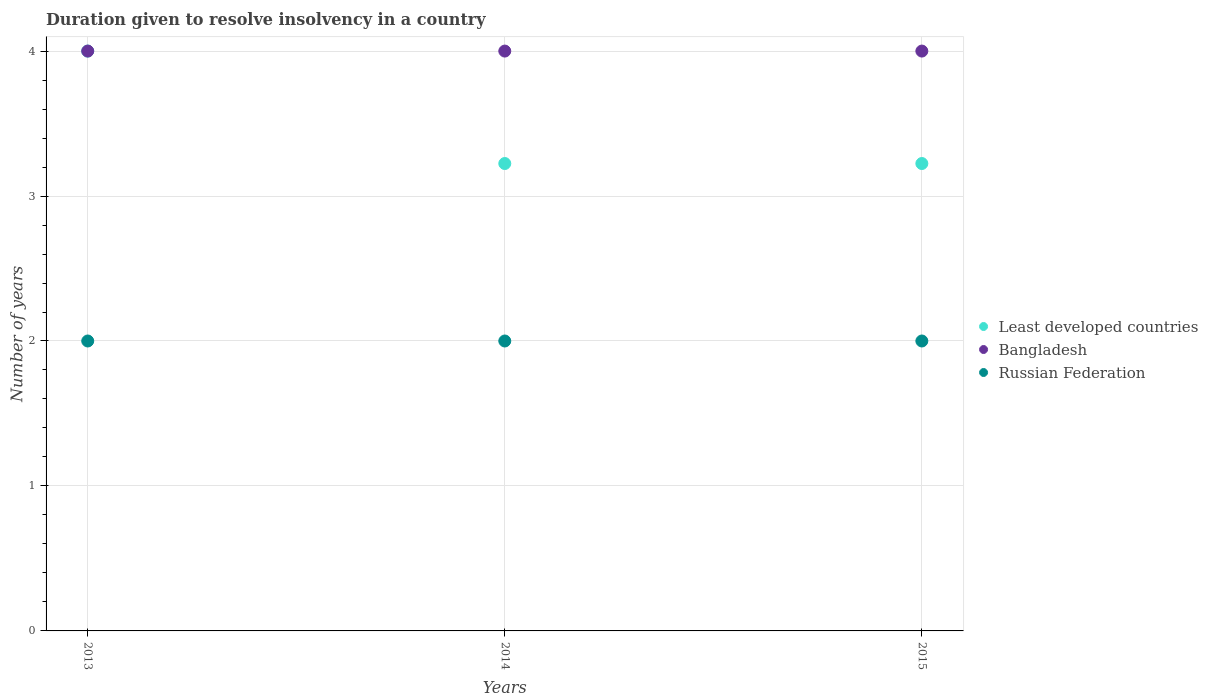Is the number of dotlines equal to the number of legend labels?
Ensure brevity in your answer.  Yes. What is the duration given to resolve insolvency in in Russian Federation in 2014?
Give a very brief answer. 2. Across all years, what is the maximum duration given to resolve insolvency in in Least developed countries?
Your response must be concise. 4. Across all years, what is the minimum duration given to resolve insolvency in in Least developed countries?
Offer a terse response. 3.22. In which year was the duration given to resolve insolvency in in Russian Federation maximum?
Provide a short and direct response. 2013. What is the total duration given to resolve insolvency in in Bangladesh in the graph?
Your answer should be very brief. 12. What is the difference between the duration given to resolve insolvency in in Russian Federation in 2015 and the duration given to resolve insolvency in in Bangladesh in 2014?
Keep it short and to the point. -2. What is the average duration given to resolve insolvency in in Least developed countries per year?
Make the answer very short. 3.48. In the year 2013, what is the difference between the duration given to resolve insolvency in in Least developed countries and duration given to resolve insolvency in in Russian Federation?
Make the answer very short. 2. In how many years, is the duration given to resolve insolvency in in Bangladesh greater than 2 years?
Provide a short and direct response. 3. What is the ratio of the duration given to resolve insolvency in in Least developed countries in 2014 to that in 2015?
Offer a terse response. 1. What is the difference between the highest and the second highest duration given to resolve insolvency in in Russian Federation?
Offer a very short reply. 0. What is the difference between the highest and the lowest duration given to resolve insolvency in in Least developed countries?
Offer a terse response. 0.78. Does the duration given to resolve insolvency in in Russian Federation monotonically increase over the years?
Make the answer very short. No. Is the duration given to resolve insolvency in in Least developed countries strictly greater than the duration given to resolve insolvency in in Russian Federation over the years?
Keep it short and to the point. Yes. How many dotlines are there?
Give a very brief answer. 3. What is the difference between two consecutive major ticks on the Y-axis?
Make the answer very short. 1. Are the values on the major ticks of Y-axis written in scientific E-notation?
Ensure brevity in your answer.  No. Does the graph contain any zero values?
Make the answer very short. No. How many legend labels are there?
Your answer should be compact. 3. How are the legend labels stacked?
Your response must be concise. Vertical. What is the title of the graph?
Provide a short and direct response. Duration given to resolve insolvency in a country. What is the label or title of the X-axis?
Make the answer very short. Years. What is the label or title of the Y-axis?
Give a very brief answer. Number of years. What is the Number of years in Bangladesh in 2013?
Your answer should be compact. 4. What is the Number of years in Russian Federation in 2013?
Your answer should be compact. 2. What is the Number of years in Least developed countries in 2014?
Keep it short and to the point. 3.22. What is the Number of years of Least developed countries in 2015?
Keep it short and to the point. 3.22. What is the Number of years of Bangladesh in 2015?
Make the answer very short. 4. Across all years, what is the maximum Number of years in Bangladesh?
Offer a very short reply. 4. Across all years, what is the maximum Number of years in Russian Federation?
Give a very brief answer. 2. Across all years, what is the minimum Number of years in Least developed countries?
Your answer should be very brief. 3.22. What is the total Number of years in Least developed countries in the graph?
Your response must be concise. 10.45. What is the total Number of years in Bangladesh in the graph?
Keep it short and to the point. 12. What is the total Number of years of Russian Federation in the graph?
Offer a terse response. 6. What is the difference between the Number of years in Least developed countries in 2013 and that in 2014?
Make the answer very short. 0.78. What is the difference between the Number of years in Least developed countries in 2013 and that in 2015?
Offer a terse response. 0.78. What is the difference between the Number of years in Bangladesh in 2013 and that in 2015?
Make the answer very short. 0. What is the difference between the Number of years of Russian Federation in 2013 and that in 2015?
Offer a very short reply. 0. What is the difference between the Number of years in Least developed countries in 2014 and that in 2015?
Provide a short and direct response. 0. What is the difference between the Number of years of Least developed countries in 2013 and the Number of years of Russian Federation in 2014?
Give a very brief answer. 2. What is the difference between the Number of years of Bangladesh in 2013 and the Number of years of Russian Federation in 2014?
Make the answer very short. 2. What is the difference between the Number of years of Least developed countries in 2014 and the Number of years of Bangladesh in 2015?
Offer a very short reply. -0.78. What is the difference between the Number of years in Least developed countries in 2014 and the Number of years in Russian Federation in 2015?
Your response must be concise. 1.22. What is the average Number of years in Least developed countries per year?
Provide a short and direct response. 3.48. What is the average Number of years in Bangladesh per year?
Provide a succinct answer. 4. In the year 2013, what is the difference between the Number of years of Least developed countries and Number of years of Bangladesh?
Offer a terse response. 0. In the year 2013, what is the difference between the Number of years of Least developed countries and Number of years of Russian Federation?
Provide a succinct answer. 2. In the year 2014, what is the difference between the Number of years of Least developed countries and Number of years of Bangladesh?
Offer a very short reply. -0.78. In the year 2014, what is the difference between the Number of years of Least developed countries and Number of years of Russian Federation?
Provide a short and direct response. 1.22. In the year 2015, what is the difference between the Number of years of Least developed countries and Number of years of Bangladesh?
Ensure brevity in your answer.  -0.78. In the year 2015, what is the difference between the Number of years of Least developed countries and Number of years of Russian Federation?
Your answer should be very brief. 1.22. In the year 2015, what is the difference between the Number of years in Bangladesh and Number of years in Russian Federation?
Offer a terse response. 2. What is the ratio of the Number of years in Least developed countries in 2013 to that in 2014?
Your answer should be compact. 1.24. What is the ratio of the Number of years of Russian Federation in 2013 to that in 2014?
Keep it short and to the point. 1. What is the ratio of the Number of years in Least developed countries in 2013 to that in 2015?
Make the answer very short. 1.24. What is the ratio of the Number of years in Russian Federation in 2014 to that in 2015?
Make the answer very short. 1. What is the difference between the highest and the second highest Number of years in Least developed countries?
Keep it short and to the point. 0.78. What is the difference between the highest and the second highest Number of years of Bangladesh?
Ensure brevity in your answer.  0. What is the difference between the highest and the second highest Number of years of Russian Federation?
Give a very brief answer. 0. What is the difference between the highest and the lowest Number of years in Least developed countries?
Your answer should be very brief. 0.78. 